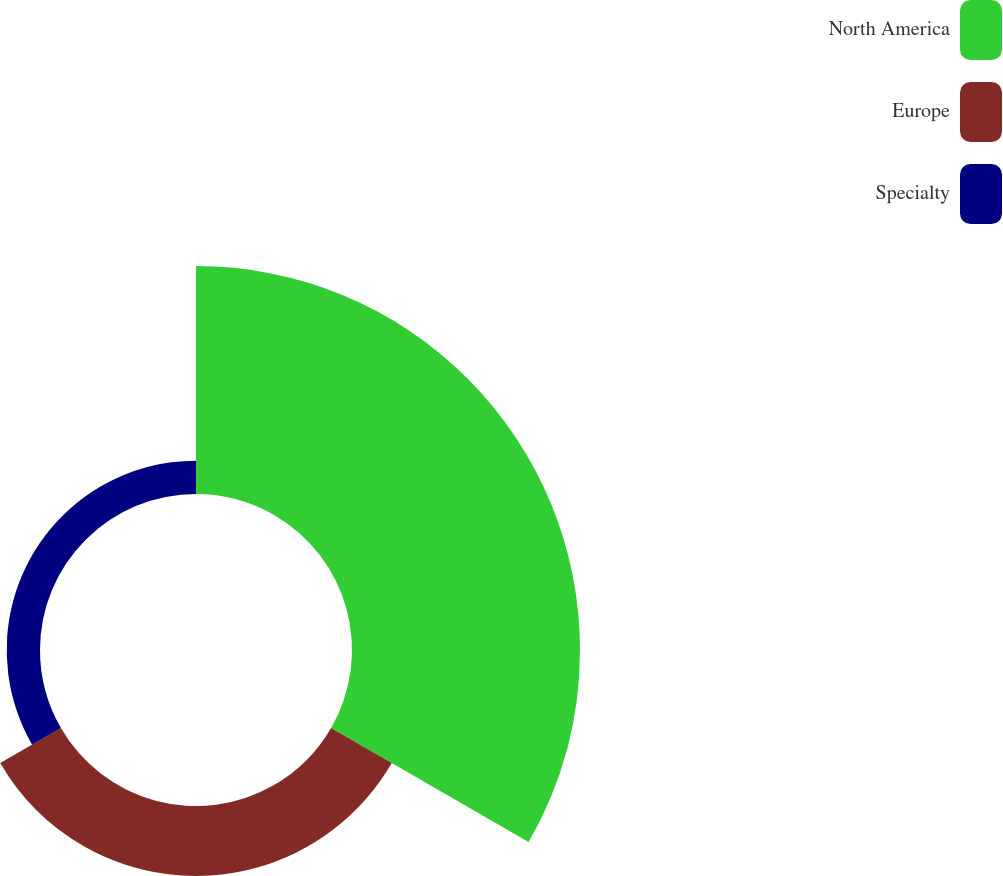<chart> <loc_0><loc_0><loc_500><loc_500><pie_chart><fcel>North America<fcel>Europe<fcel>Specialty<nl><fcel>68.81%<fcel>21.14%<fcel>10.05%<nl></chart> 